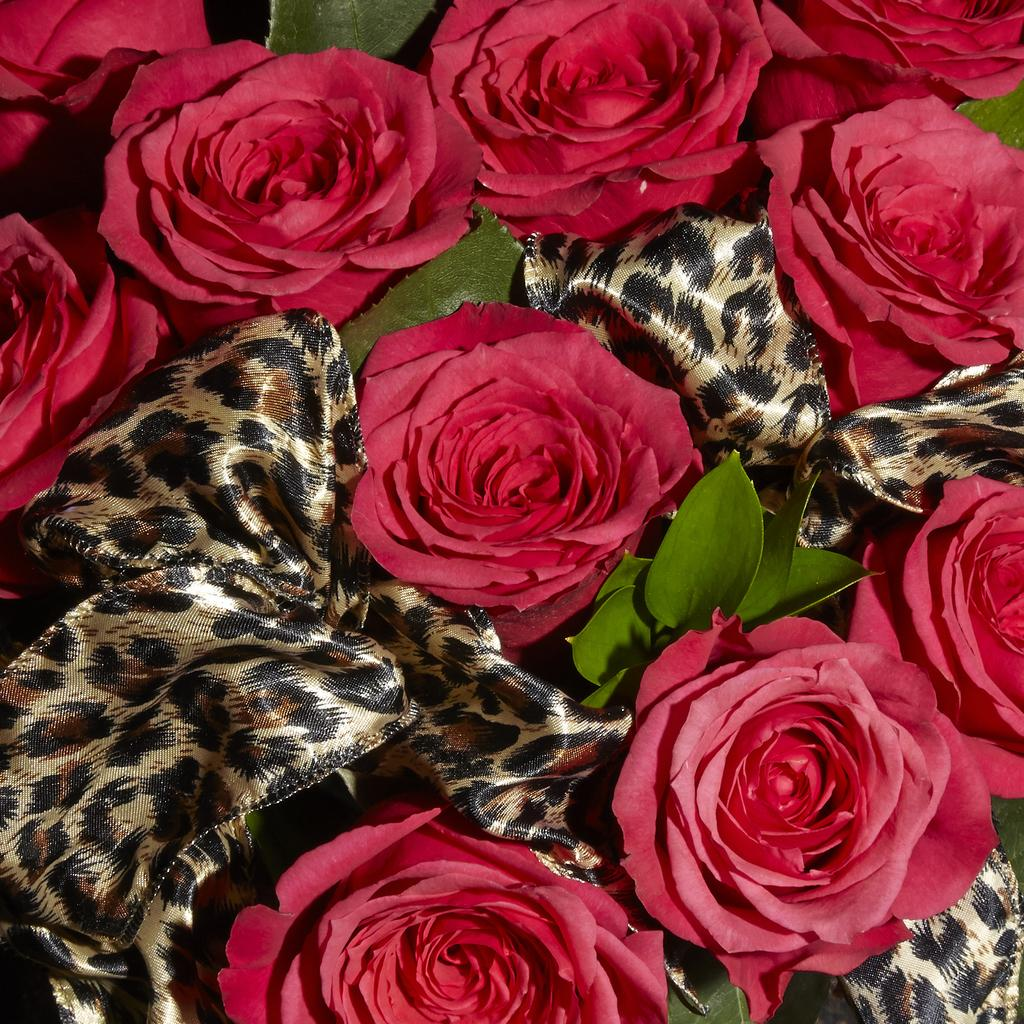What type of flowers are in the image? There are rose flowers in the image. What is the color and pattern of the cloth in the image? The cloth in the image has a black and gold color pattern. What color are the leaves in the image? The leaves in the image are green. What type of string is used to tie the pump in the image? There is no pump present in the image, so it is not possible to determine what type of string might be used to tie it. 